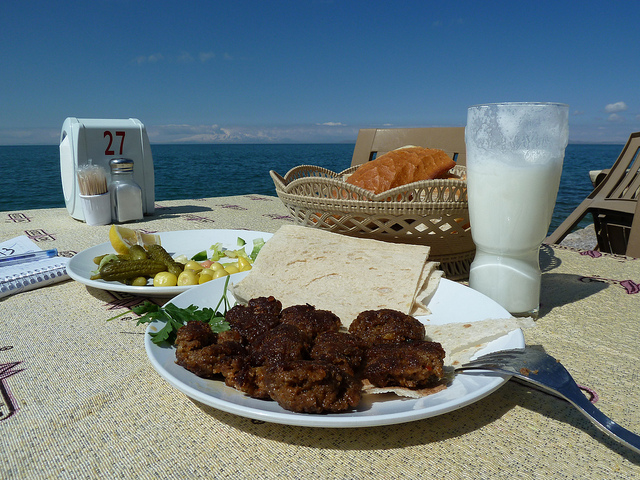Describe what you think is happening in this image. This image appears to capture a peaceful dining setup by the seaside. A plate of delicious food, bread, and a glass of milk are placed neatly on a table with the ocean providing a stunning backdrop. It looks like a perfect setting for someone to enjoy a relaxing meal while taking in the beautiful view. What kind of food is being served? The plate contains what seems to be a variety of different foods: a portion of meatballs or kebabs, fresh vegetables, some pickles, flatbreads, and possibly a yogurt-based drink. This combination suggests a delicious and balanced meal, likely influenced by Mediterranean or Middle Eastern cuisine. 